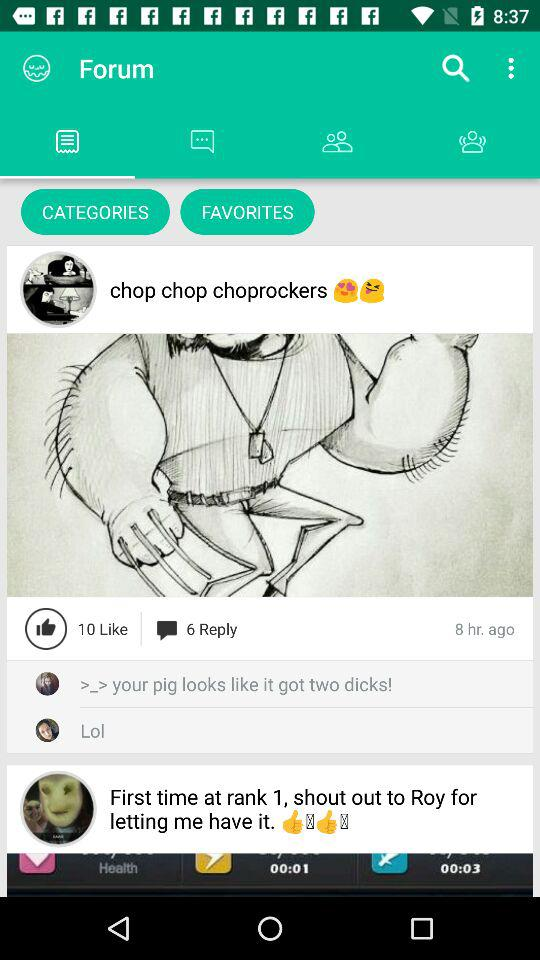How many hours ago was the post posted? The post was posted 8 hours ago. 